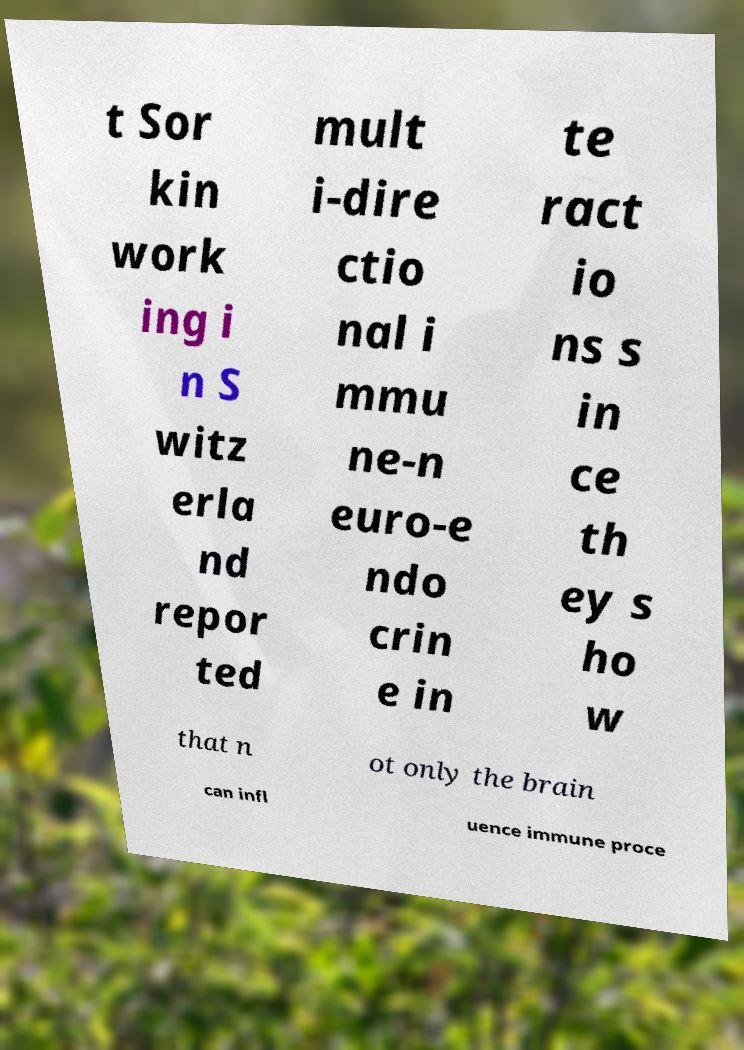I need the written content from this picture converted into text. Can you do that? t Sor kin work ing i n S witz erla nd repor ted mult i-dire ctio nal i mmu ne-n euro-e ndo crin e in te ract io ns s in ce th ey s ho w that n ot only the brain can infl uence immune proce 